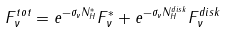Convert formula to latex. <formula><loc_0><loc_0><loc_500><loc_500>F _ { \nu } ^ { t o t } = e ^ { - \sigma _ { \nu } N _ { H } ^ { * } } F _ { \nu } ^ { * } + e ^ { - \sigma _ { \nu } N _ { H } ^ { d i s k } } F _ { \nu } ^ { d i s k }</formula> 